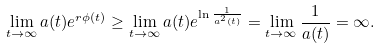Convert formula to latex. <formula><loc_0><loc_0><loc_500><loc_500>\lim _ { t \to \infty } a ( t ) e ^ { r \phi ( t ) } \geq \lim _ { t \to \infty } a ( t ) e ^ { \ln \frac { 1 } { a ^ { 2 } ( t ) } } = \lim _ { t \to \infty } \frac { 1 } { a ( t ) } = \infty .</formula> 